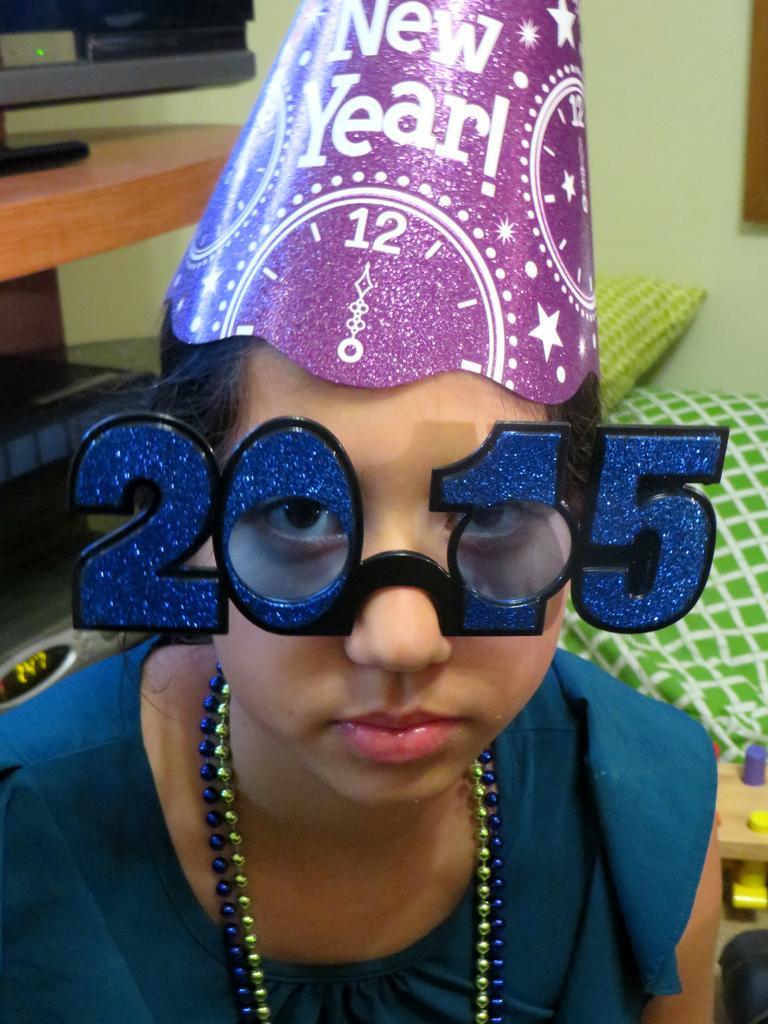How would you summarize this image in a sentence or two? In this image, we can see a person wearing fancy spectacles. We can also see the wall, a mat and a pillow. We can also see a table with an object. We can also see some objects on the left. 